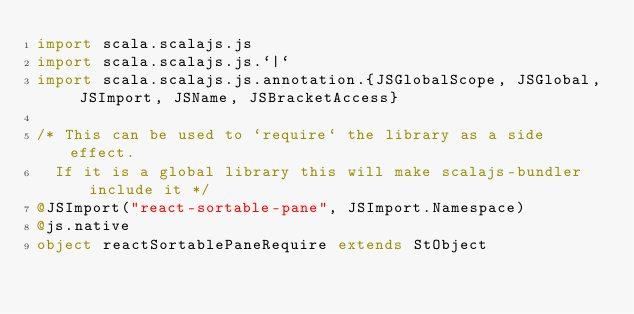Convert code to text. <code><loc_0><loc_0><loc_500><loc_500><_Scala_>import scala.scalajs.js
import scala.scalajs.js.`|`
import scala.scalajs.js.annotation.{JSGlobalScope, JSGlobal, JSImport, JSName, JSBracketAccess}

/* This can be used to `require` the library as a side effect.
  If it is a global library this will make scalajs-bundler include it */
@JSImport("react-sortable-pane", JSImport.Namespace)
@js.native
object reactSortablePaneRequire extends StObject
</code> 